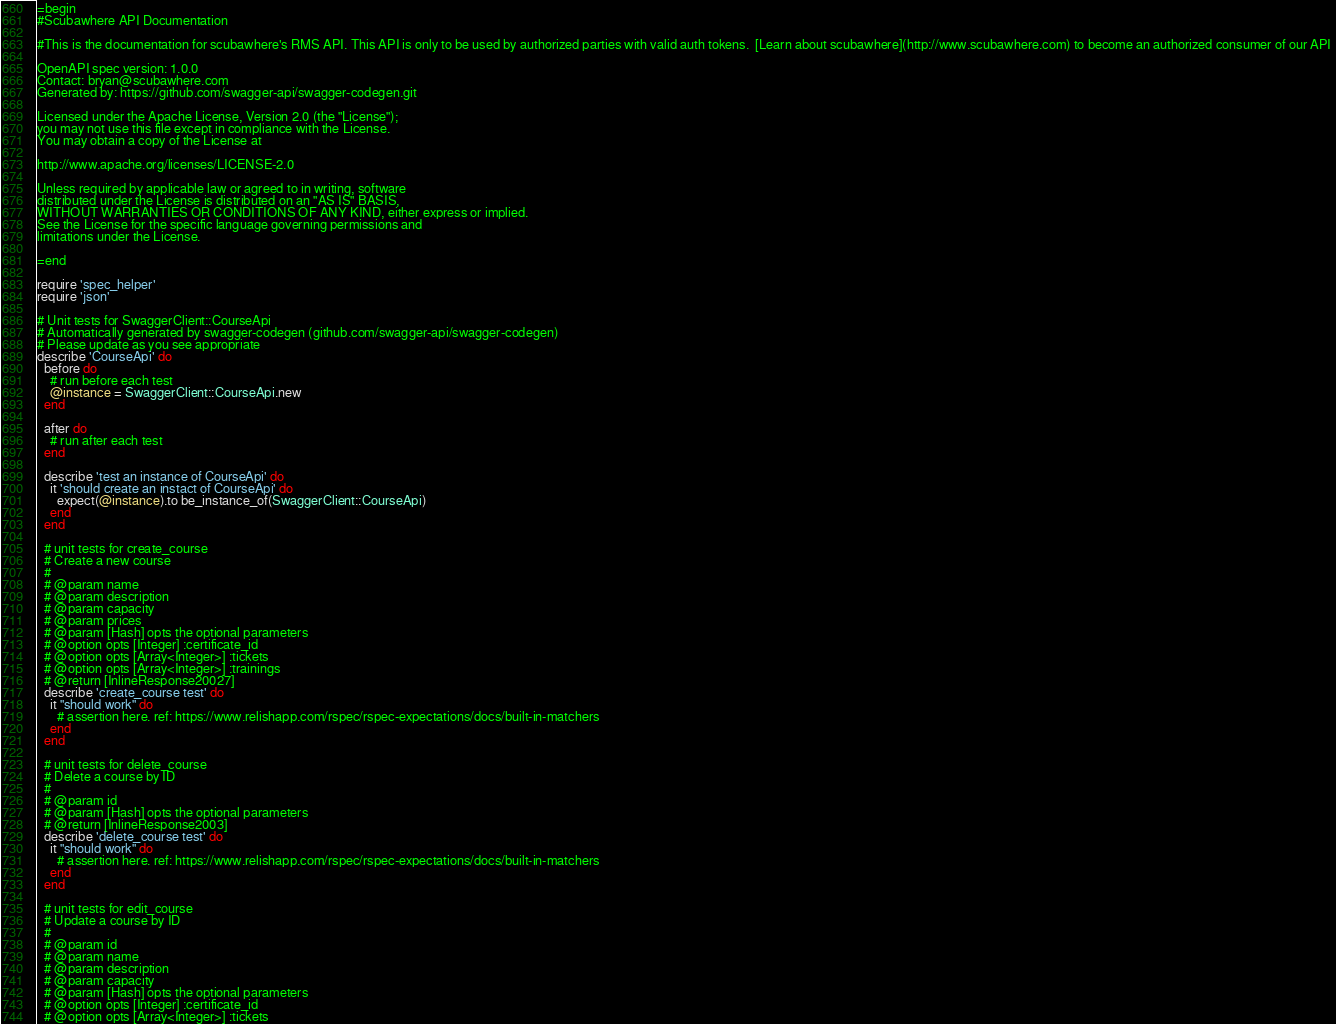Convert code to text. <code><loc_0><loc_0><loc_500><loc_500><_Ruby_>=begin
#Scubawhere API Documentation

#This is the documentation for scubawhere's RMS API. This API is only to be used by authorized parties with valid auth tokens.  [Learn about scubawhere](http://www.scubawhere.com) to become an authorized consumer of our API 

OpenAPI spec version: 1.0.0
Contact: bryan@scubawhere.com
Generated by: https://github.com/swagger-api/swagger-codegen.git

Licensed under the Apache License, Version 2.0 (the "License");
you may not use this file except in compliance with the License.
You may obtain a copy of the License at

http://www.apache.org/licenses/LICENSE-2.0

Unless required by applicable law or agreed to in writing, software
distributed under the License is distributed on an "AS IS" BASIS,
WITHOUT WARRANTIES OR CONDITIONS OF ANY KIND, either express or implied.
See the License for the specific language governing permissions and
limitations under the License.

=end

require 'spec_helper'
require 'json'

# Unit tests for SwaggerClient::CourseApi
# Automatically generated by swagger-codegen (github.com/swagger-api/swagger-codegen)
# Please update as you see appropriate
describe 'CourseApi' do
  before do
    # run before each test
    @instance = SwaggerClient::CourseApi.new
  end

  after do
    # run after each test
  end

  describe 'test an instance of CourseApi' do
    it 'should create an instact of CourseApi' do
      expect(@instance).to be_instance_of(SwaggerClient::CourseApi)
    end
  end

  # unit tests for create_course
  # Create a new course
  # 
  # @param name 
  # @param description 
  # @param capacity 
  # @param prices 
  # @param [Hash] opts the optional parameters
  # @option opts [Integer] :certificate_id 
  # @option opts [Array<Integer>] :tickets 
  # @option opts [Array<Integer>] :trainings 
  # @return [InlineResponse20027]
  describe 'create_course test' do
    it "should work" do
      # assertion here. ref: https://www.relishapp.com/rspec/rspec-expectations/docs/built-in-matchers
    end
  end

  # unit tests for delete_course
  # Delete a course by ID
  # 
  # @param id 
  # @param [Hash] opts the optional parameters
  # @return [InlineResponse2003]
  describe 'delete_course test' do
    it "should work" do
      # assertion here. ref: https://www.relishapp.com/rspec/rspec-expectations/docs/built-in-matchers
    end
  end

  # unit tests for edit_course
  # Update a course by ID
  # 
  # @param id 
  # @param name 
  # @param description 
  # @param capacity 
  # @param [Hash] opts the optional parameters
  # @option opts [Integer] :certificate_id 
  # @option opts [Array<Integer>] :tickets </code> 